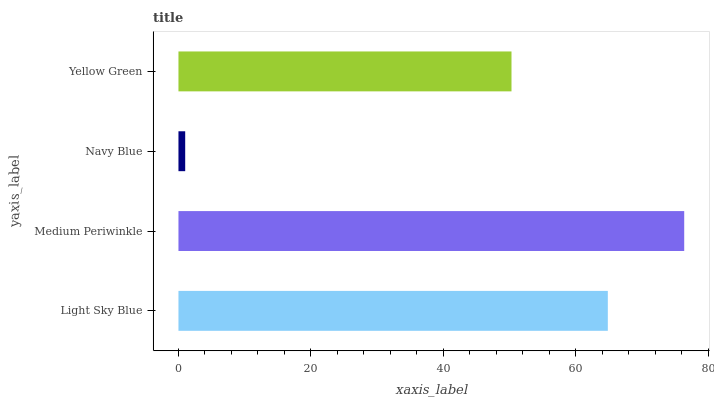Is Navy Blue the minimum?
Answer yes or no. Yes. Is Medium Periwinkle the maximum?
Answer yes or no. Yes. Is Medium Periwinkle the minimum?
Answer yes or no. No. Is Navy Blue the maximum?
Answer yes or no. No. Is Medium Periwinkle greater than Navy Blue?
Answer yes or no. Yes. Is Navy Blue less than Medium Periwinkle?
Answer yes or no. Yes. Is Navy Blue greater than Medium Periwinkle?
Answer yes or no. No. Is Medium Periwinkle less than Navy Blue?
Answer yes or no. No. Is Light Sky Blue the high median?
Answer yes or no. Yes. Is Yellow Green the low median?
Answer yes or no. Yes. Is Navy Blue the high median?
Answer yes or no. No. Is Navy Blue the low median?
Answer yes or no. No. 